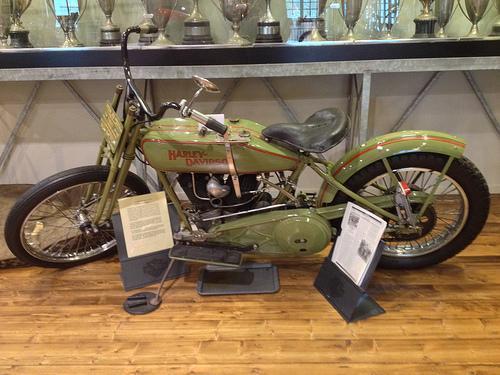How many wheels are there?
Give a very brief answer. 2. How many motorcycles are there?
Give a very brief answer. 1. How many bikes?
Give a very brief answer. 1. How many tires?
Give a very brief answer. 2. 